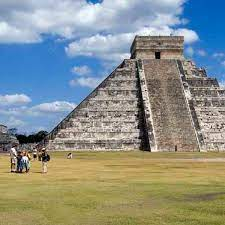Imagine the pyramid in a fantastical world where it serves as a portal to other realms. What kind of adventures might unfold? In a fantastical world where the pyramid of Chichen Itza serves as a portal to other realms, countless adventures could unfold. As you ascend the steps to the temple at the top, an ancient inscription activates a shimmering portal, transporting you to a parallel universe brimming with mythical creatures and undiscovered civilizations. You might find yourself amidst towering jungle trees, where talking jaguars and serpentine dragons guard hidden treasures. Exploring further, you could uncover a realm where the stars are closer, and celestial beings offer guidance in solving cosmic puzzles that have the power to alter time and space. Each journey through the portal could lead you to a new realm with distinct challenges and wonders, requiring you to harness both knowledge and bravery to navigate the twists and turns of these alternate dimensions. You could even find yourself in a futuristic world, where the ancient Mayan wisdom is integrated with advanced technology, presenting a harmonious society that holds the secrets to universal peace and prosperity. 